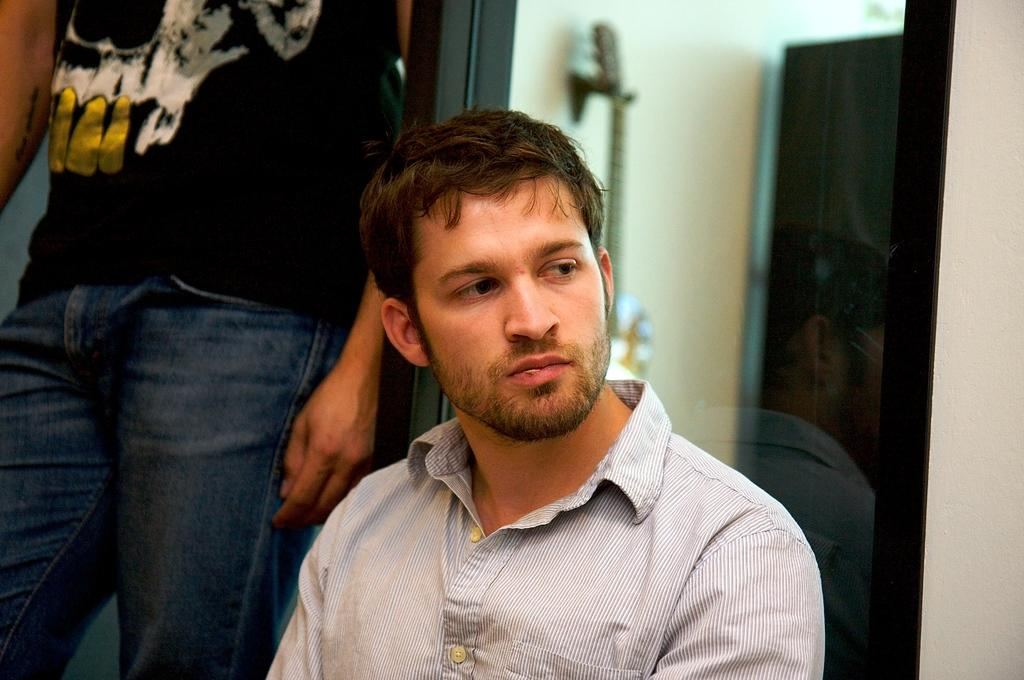How many people are in the image? There are two people in the image. What colors are the dresses worn by the people in the image? One person is wearing a black dress, and the other person is wearing a blue dress. What color is the dress worn by the third person mentioned in the facts? The third person is wearing an ash-colored dress. What can be seen in the background of the image? There is a glass wall visible in the background of the image. What type of mask is the person wearing in the image? There is no mask visible in the image; both people are wearing dresses. What knowledge is being shared between the two people in the image? The image does not provide any information about the conversation or knowledge being shared between the two people. 